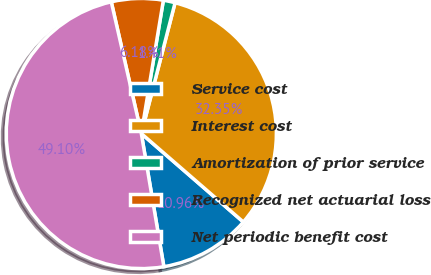<chart> <loc_0><loc_0><loc_500><loc_500><pie_chart><fcel>Service cost<fcel>Interest cost<fcel>Amortization of prior service<fcel>Recognized net actuarial loss<fcel>Net periodic benefit cost<nl><fcel>10.96%<fcel>32.35%<fcel>1.41%<fcel>6.18%<fcel>49.1%<nl></chart> 